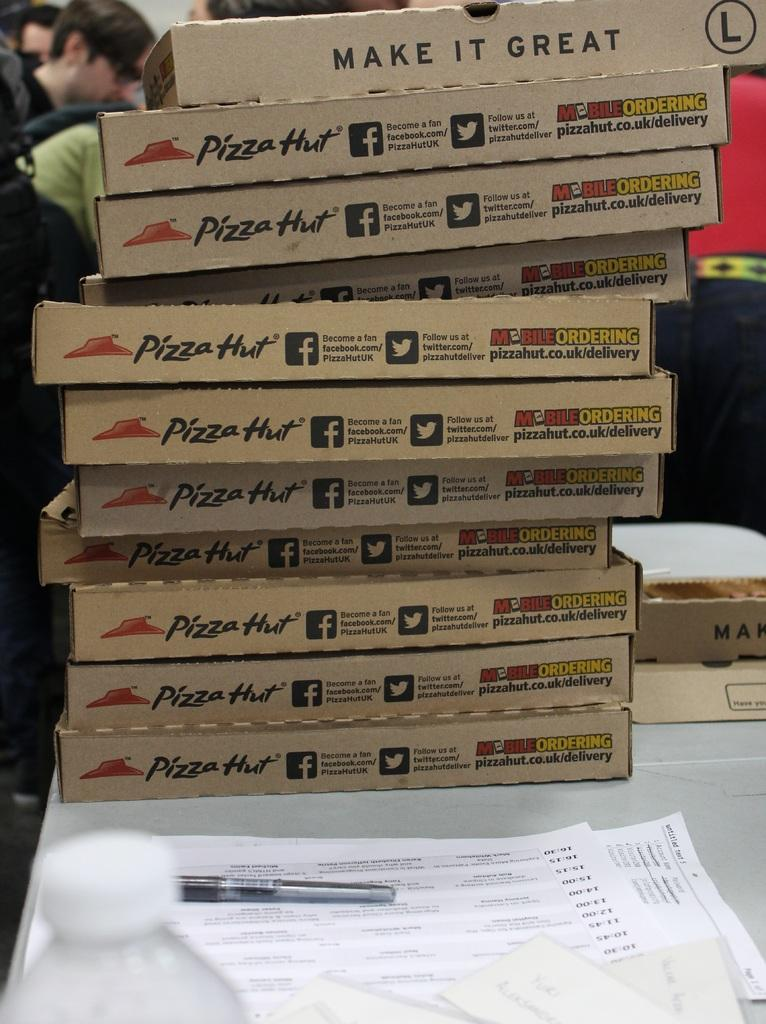What type of food is present in the image? There are pizza boxes on the table, which suggests pizza is present in the image. What else can be seen on the table besides pizza boxes? There are papers and a pen on the table. Can you describe any other objects on the table? There are other objects on the table, but their specific nature is not mentioned in the facts. Are there any people in the image? Yes, there are people present in the image. Can you describe the grass and giraffes in the image? There is no grass or giraffes present in the image. How many chickens are visible in the image? There are no chickens present in the image. 